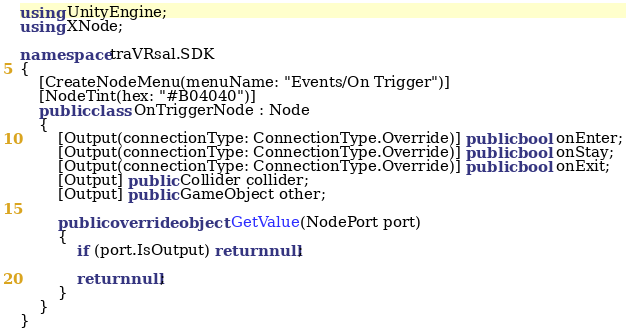Convert code to text. <code><loc_0><loc_0><loc_500><loc_500><_C#_>using UnityEngine;
using XNode;

namespace traVRsal.SDK
{
    [CreateNodeMenu(menuName: "Events/On Trigger")]
    [NodeTint(hex: "#B04040")]
    public class OnTriggerNode : Node
    {
        [Output(connectionType: ConnectionType.Override)] public bool onEnter;
        [Output(connectionType: ConnectionType.Override)] public bool onStay;
        [Output(connectionType: ConnectionType.Override)] public bool onExit;
        [Output] public Collider collider;
        [Output] public GameObject other;

        public override object GetValue(NodePort port)
        {
            if (port.IsOutput) return null;

            return null;
        }
    }
}</code> 